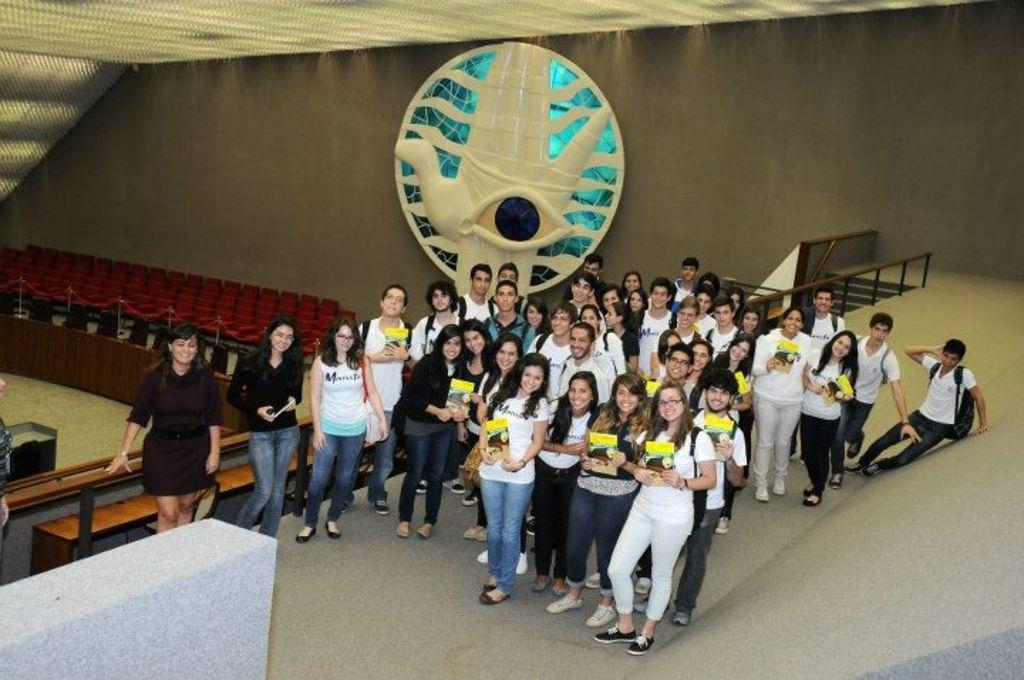What is the main subject of the image? The main subject of the image is a crowd of people. What are the people in the image doing? The people are standing on the floor and holding books in their hands. What can be seen in the background of the image? In the background of the image, there are railing poles, walls, and chairs. Can you tell me how the maid is cleaning the floor in the image? There is no maid present in the image, and the people are holding books, not cleaning the floor. 